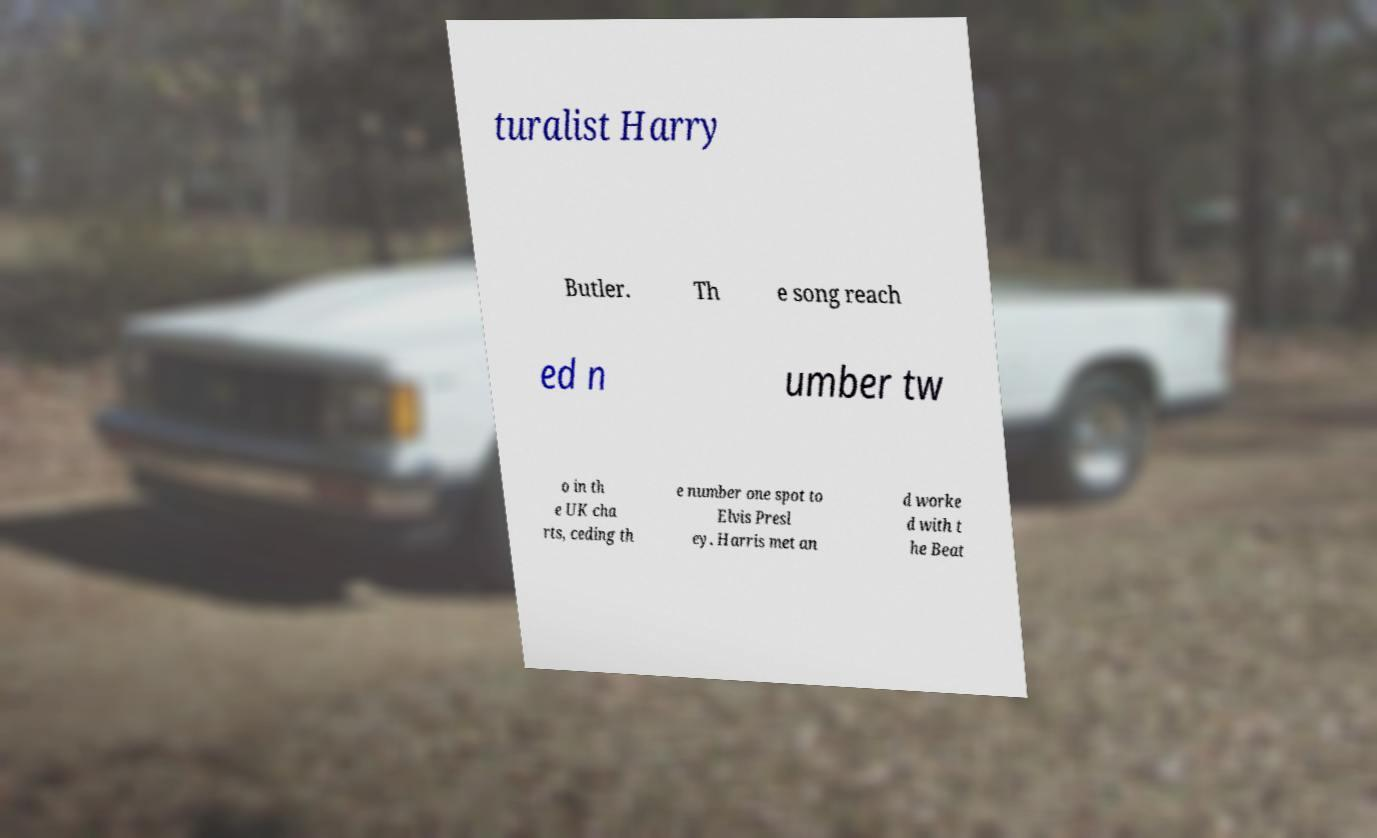I need the written content from this picture converted into text. Can you do that? turalist Harry Butler. Th e song reach ed n umber tw o in th e UK cha rts, ceding th e number one spot to Elvis Presl ey. Harris met an d worke d with t he Beat 